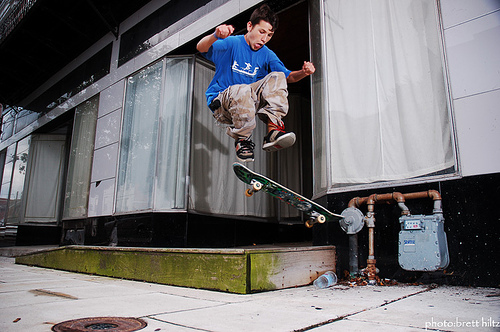Please transcribe the text in this image. brettsa 